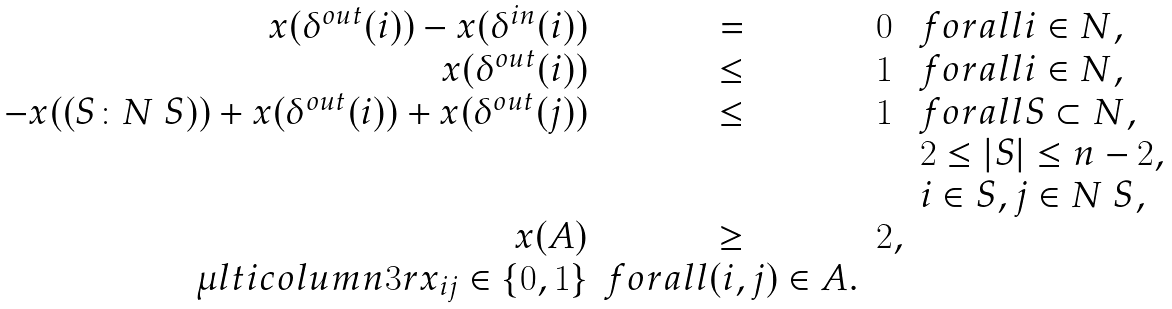Convert formula to latex. <formula><loc_0><loc_0><loc_500><loc_500>\begin{array} { r c l l } x ( \delta ^ { o u t } ( i ) ) - x ( \delta ^ { i n } ( i ) ) & = & 0 & f o r a l l i \in N , \\ x ( \delta ^ { o u t } ( i ) ) & \leq & 1 & f o r a l l i \in N , \\ - x ( ( S \colon N \ S ) ) + x ( \delta ^ { o u t } ( i ) ) + x ( \delta ^ { o u t } ( j ) ) & \leq & 1 & f o r a l l S \subset N , \\ & & & 2 \leq | S | \leq n - 2 , \\ & & & i \in S , j \in N \ S , \\ x ( A ) & \geq & 2 , \\ \mu l t i c o l u m n { 3 } { r } { x _ { i j } \in \{ 0 , 1 \} } & f o r a l l ( i , j ) \in A . \end{array}</formula> 